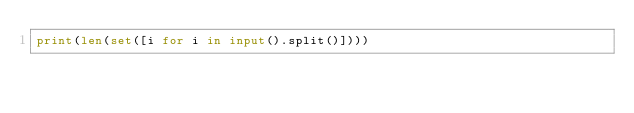<code> <loc_0><loc_0><loc_500><loc_500><_Python_>print(len(set([i for i in input().split()])))</code> 